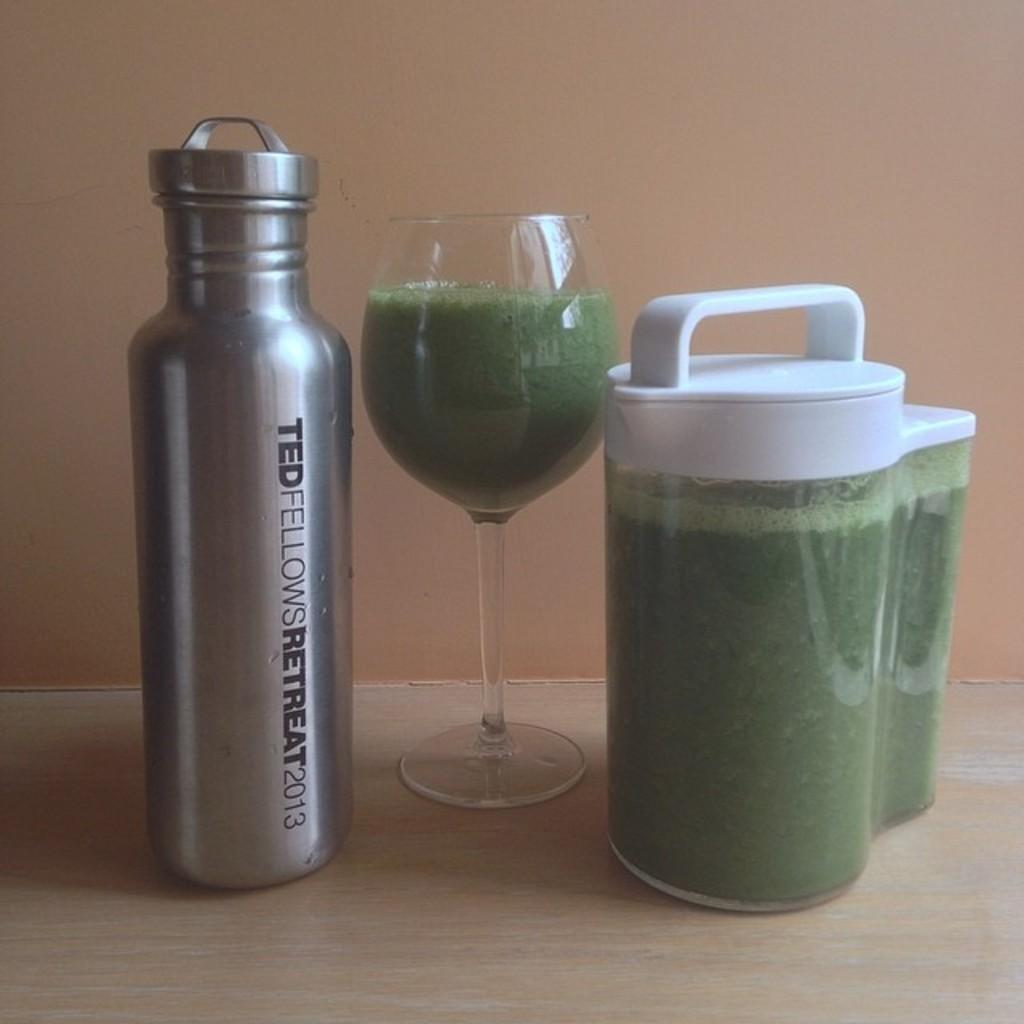<image>
Offer a succinct explanation of the picture presented. an aluminum flask that says 'ted fellows retreat 2013' on it 